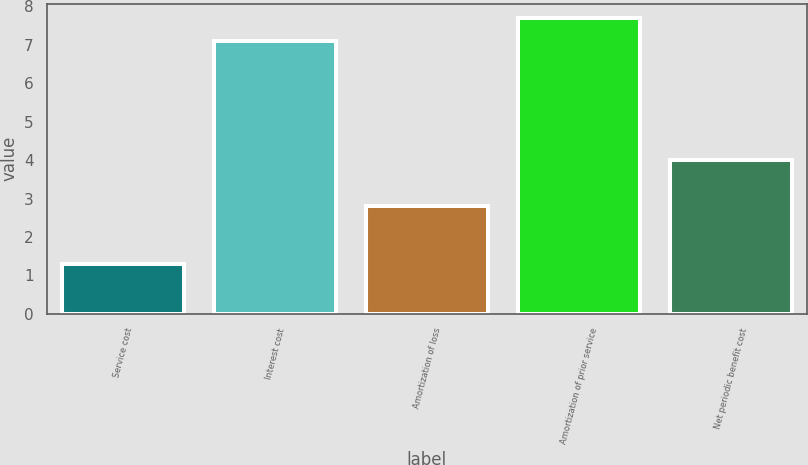Convert chart to OTSL. <chart><loc_0><loc_0><loc_500><loc_500><bar_chart><fcel>Service cost<fcel>Interest cost<fcel>Amortization of loss<fcel>Amortization of prior service<fcel>Net periodic benefit cost<nl><fcel>1.3<fcel>7.1<fcel>2.8<fcel>7.69<fcel>4<nl></chart> 